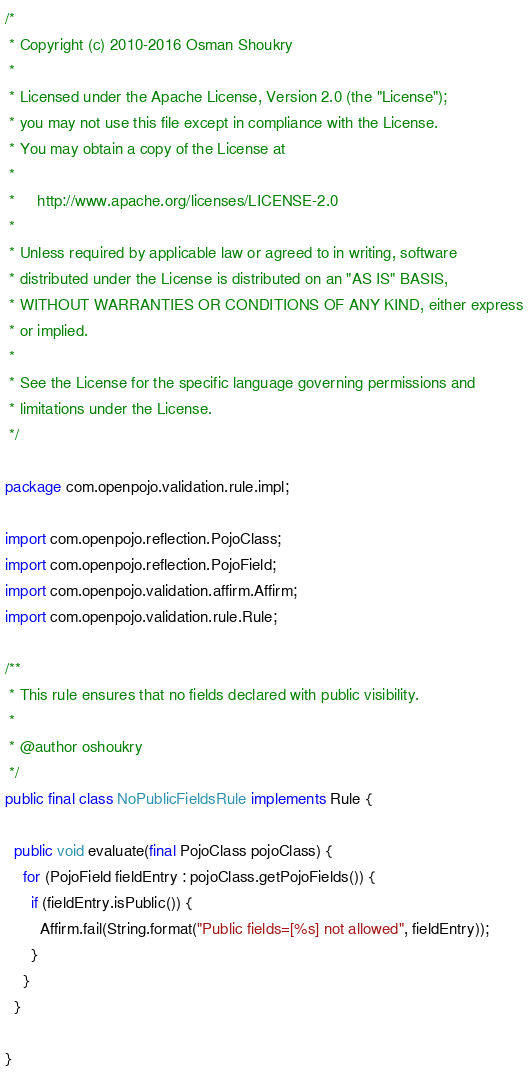<code> <loc_0><loc_0><loc_500><loc_500><_Java_>/*
 * Copyright (c) 2010-2016 Osman Shoukry
 *
 * Licensed under the Apache License, Version 2.0 (the "License");
 * you may not use this file except in compliance with the License.
 * You may obtain a copy of the License at
 *
 *     http://www.apache.org/licenses/LICENSE-2.0
 *
 * Unless required by applicable law or agreed to in writing, software
 * distributed under the License is distributed on an "AS IS" BASIS,
 * WITHOUT WARRANTIES OR CONDITIONS OF ANY KIND, either express
 * or implied.
 *
 * See the License for the specific language governing permissions and
 * limitations under the License.
 */

package com.openpojo.validation.rule.impl;

import com.openpojo.reflection.PojoClass;
import com.openpojo.reflection.PojoField;
import com.openpojo.validation.affirm.Affirm;
import com.openpojo.validation.rule.Rule;

/**
 * This rule ensures that no fields declared with public visibility.
 *
 * @author oshoukry
 */
public final class NoPublicFieldsRule implements Rule {

  public void evaluate(final PojoClass pojoClass) {
    for (PojoField fieldEntry : pojoClass.getPojoFields()) {
      if (fieldEntry.isPublic()) {
        Affirm.fail(String.format("Public fields=[%s] not allowed", fieldEntry));
      }
    }
  }

}
</code> 